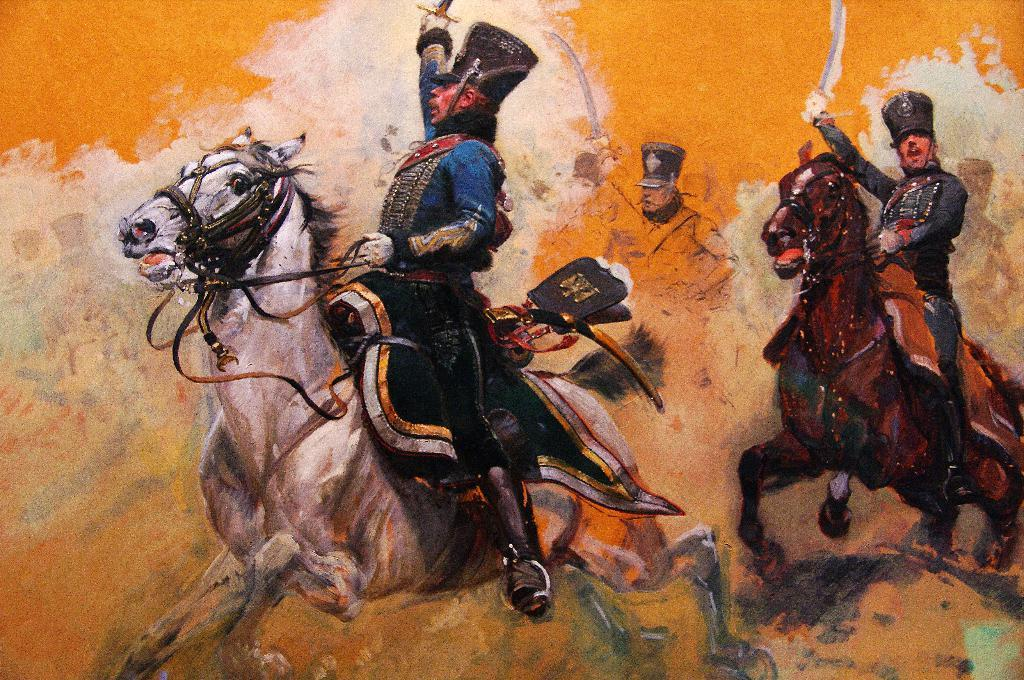Who is present in the image? There are people in the image. What are the people doing in the image? The people are sitting on horses. What are the people holding in the image? The people are holding weapons. What type of home does the writer live in, as seen in the image? There is no writer or home present in the image; it features people sitting on horses and holding weapons. 